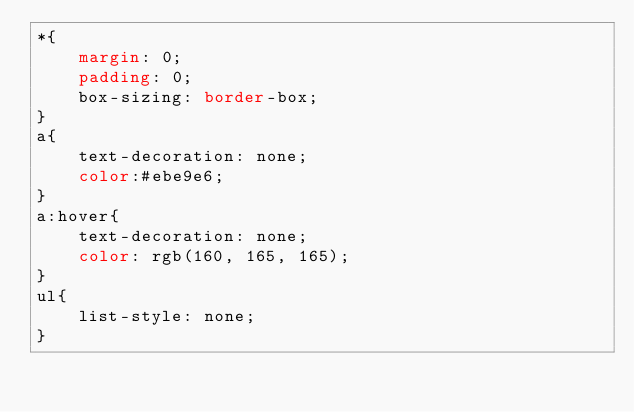<code> <loc_0><loc_0><loc_500><loc_500><_CSS_>*{
    margin: 0;
    padding: 0;
    box-sizing: border-box;
}
a{
    text-decoration: none;
    color:#ebe9e6;
}
a:hover{
    text-decoration: none;
    color: rgb(160, 165, 165);
}
ul{
    list-style: none;
}</code> 